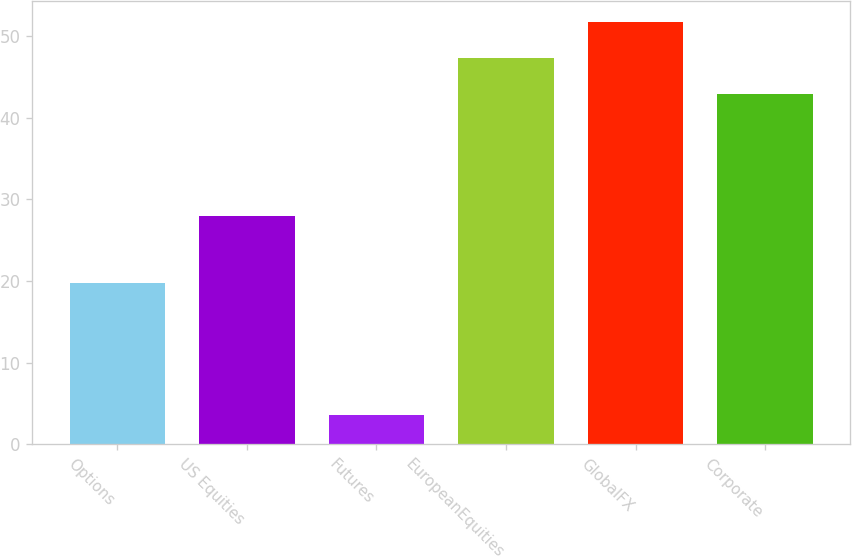Convert chart to OTSL. <chart><loc_0><loc_0><loc_500><loc_500><bar_chart><fcel>Options<fcel>US Equities<fcel>Futures<fcel>EuropeanEquities<fcel>GlobalFX<fcel>Corporate<nl><fcel>19.7<fcel>28<fcel>3.6<fcel>47.3<fcel>51.7<fcel>42.9<nl></chart> 